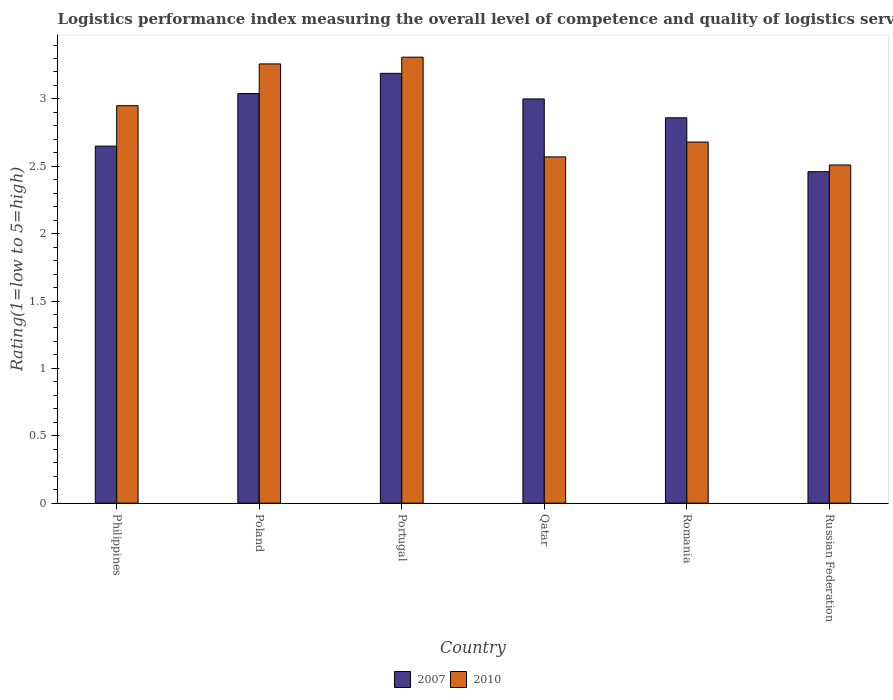How many different coloured bars are there?
Your answer should be compact. 2. How many groups of bars are there?
Your response must be concise. 6. Are the number of bars per tick equal to the number of legend labels?
Your answer should be compact. Yes. Are the number of bars on each tick of the X-axis equal?
Your answer should be very brief. Yes. How many bars are there on the 5th tick from the left?
Offer a terse response. 2. What is the label of the 6th group of bars from the left?
Give a very brief answer. Russian Federation. In how many cases, is the number of bars for a given country not equal to the number of legend labels?
Offer a very short reply. 0. What is the Logistic performance index in 2010 in Qatar?
Your answer should be very brief. 2.57. Across all countries, what is the maximum Logistic performance index in 2010?
Give a very brief answer. 3.31. Across all countries, what is the minimum Logistic performance index in 2010?
Make the answer very short. 2.51. In which country was the Logistic performance index in 2010 minimum?
Ensure brevity in your answer.  Russian Federation. What is the total Logistic performance index in 2010 in the graph?
Give a very brief answer. 17.28. What is the difference between the Logistic performance index in 2007 in Qatar and that in Russian Federation?
Offer a terse response. 0.54. What is the difference between the Logistic performance index in 2010 in Poland and the Logistic performance index in 2007 in Portugal?
Make the answer very short. 0.07. What is the average Logistic performance index in 2010 per country?
Ensure brevity in your answer.  2.88. What is the difference between the Logistic performance index of/in 2010 and Logistic performance index of/in 2007 in Philippines?
Make the answer very short. 0.3. In how many countries, is the Logistic performance index in 2007 greater than 2.3?
Keep it short and to the point. 6. What is the ratio of the Logistic performance index in 2010 in Poland to that in Romania?
Offer a very short reply. 1.22. Is the Logistic performance index in 2010 in Qatar less than that in Romania?
Your response must be concise. Yes. What is the difference between the highest and the second highest Logistic performance index in 2010?
Your answer should be compact. 0.31. What is the difference between the highest and the lowest Logistic performance index in 2007?
Your response must be concise. 0.73. In how many countries, is the Logistic performance index in 2010 greater than the average Logistic performance index in 2010 taken over all countries?
Keep it short and to the point. 3. Is the sum of the Logistic performance index in 2010 in Portugal and Qatar greater than the maximum Logistic performance index in 2007 across all countries?
Your answer should be compact. Yes. What does the 2nd bar from the left in Portugal represents?
Provide a short and direct response. 2010. What does the 1st bar from the right in Philippines represents?
Offer a very short reply. 2010. How many bars are there?
Ensure brevity in your answer.  12. How many countries are there in the graph?
Provide a short and direct response. 6. What is the difference between two consecutive major ticks on the Y-axis?
Ensure brevity in your answer.  0.5. Does the graph contain any zero values?
Offer a terse response. No. Does the graph contain grids?
Your response must be concise. No. How are the legend labels stacked?
Provide a short and direct response. Horizontal. What is the title of the graph?
Provide a short and direct response. Logistics performance index measuring the overall level of competence and quality of logistics services. What is the label or title of the Y-axis?
Your answer should be very brief. Rating(1=low to 5=high). What is the Rating(1=low to 5=high) in 2007 in Philippines?
Keep it short and to the point. 2.65. What is the Rating(1=low to 5=high) of 2010 in Philippines?
Offer a very short reply. 2.95. What is the Rating(1=low to 5=high) of 2007 in Poland?
Offer a terse response. 3.04. What is the Rating(1=low to 5=high) of 2010 in Poland?
Give a very brief answer. 3.26. What is the Rating(1=low to 5=high) of 2007 in Portugal?
Give a very brief answer. 3.19. What is the Rating(1=low to 5=high) in 2010 in Portugal?
Provide a short and direct response. 3.31. What is the Rating(1=low to 5=high) in 2010 in Qatar?
Your response must be concise. 2.57. What is the Rating(1=low to 5=high) of 2007 in Romania?
Your answer should be very brief. 2.86. What is the Rating(1=low to 5=high) in 2010 in Romania?
Your answer should be very brief. 2.68. What is the Rating(1=low to 5=high) of 2007 in Russian Federation?
Offer a very short reply. 2.46. What is the Rating(1=low to 5=high) in 2010 in Russian Federation?
Your answer should be very brief. 2.51. Across all countries, what is the maximum Rating(1=low to 5=high) in 2007?
Your answer should be compact. 3.19. Across all countries, what is the maximum Rating(1=low to 5=high) in 2010?
Provide a short and direct response. 3.31. Across all countries, what is the minimum Rating(1=low to 5=high) of 2007?
Provide a succinct answer. 2.46. Across all countries, what is the minimum Rating(1=low to 5=high) of 2010?
Provide a short and direct response. 2.51. What is the total Rating(1=low to 5=high) of 2010 in the graph?
Your response must be concise. 17.28. What is the difference between the Rating(1=low to 5=high) in 2007 in Philippines and that in Poland?
Give a very brief answer. -0.39. What is the difference between the Rating(1=low to 5=high) in 2010 in Philippines and that in Poland?
Your answer should be compact. -0.31. What is the difference between the Rating(1=low to 5=high) in 2007 in Philippines and that in Portugal?
Give a very brief answer. -0.54. What is the difference between the Rating(1=low to 5=high) of 2010 in Philippines and that in Portugal?
Ensure brevity in your answer.  -0.36. What is the difference between the Rating(1=low to 5=high) in 2007 in Philippines and that in Qatar?
Your response must be concise. -0.35. What is the difference between the Rating(1=low to 5=high) of 2010 in Philippines and that in Qatar?
Keep it short and to the point. 0.38. What is the difference between the Rating(1=low to 5=high) of 2007 in Philippines and that in Romania?
Offer a very short reply. -0.21. What is the difference between the Rating(1=low to 5=high) in 2010 in Philippines and that in Romania?
Offer a terse response. 0.27. What is the difference between the Rating(1=low to 5=high) of 2007 in Philippines and that in Russian Federation?
Make the answer very short. 0.19. What is the difference between the Rating(1=low to 5=high) of 2010 in Philippines and that in Russian Federation?
Offer a very short reply. 0.44. What is the difference between the Rating(1=low to 5=high) of 2007 in Poland and that in Portugal?
Give a very brief answer. -0.15. What is the difference between the Rating(1=low to 5=high) of 2010 in Poland and that in Portugal?
Ensure brevity in your answer.  -0.05. What is the difference between the Rating(1=low to 5=high) of 2010 in Poland and that in Qatar?
Your response must be concise. 0.69. What is the difference between the Rating(1=low to 5=high) in 2007 in Poland and that in Romania?
Your response must be concise. 0.18. What is the difference between the Rating(1=low to 5=high) in 2010 in Poland and that in Romania?
Ensure brevity in your answer.  0.58. What is the difference between the Rating(1=low to 5=high) of 2007 in Poland and that in Russian Federation?
Give a very brief answer. 0.58. What is the difference between the Rating(1=low to 5=high) of 2007 in Portugal and that in Qatar?
Offer a terse response. 0.19. What is the difference between the Rating(1=low to 5=high) in 2010 in Portugal and that in Qatar?
Your answer should be very brief. 0.74. What is the difference between the Rating(1=low to 5=high) in 2007 in Portugal and that in Romania?
Offer a terse response. 0.33. What is the difference between the Rating(1=low to 5=high) in 2010 in Portugal and that in Romania?
Your answer should be compact. 0.63. What is the difference between the Rating(1=low to 5=high) of 2007 in Portugal and that in Russian Federation?
Give a very brief answer. 0.73. What is the difference between the Rating(1=low to 5=high) in 2010 in Portugal and that in Russian Federation?
Offer a very short reply. 0.8. What is the difference between the Rating(1=low to 5=high) in 2007 in Qatar and that in Romania?
Make the answer very short. 0.14. What is the difference between the Rating(1=low to 5=high) in 2010 in Qatar and that in Romania?
Your answer should be very brief. -0.11. What is the difference between the Rating(1=low to 5=high) in 2007 in Qatar and that in Russian Federation?
Provide a succinct answer. 0.54. What is the difference between the Rating(1=low to 5=high) in 2007 in Romania and that in Russian Federation?
Your response must be concise. 0.4. What is the difference between the Rating(1=low to 5=high) in 2010 in Romania and that in Russian Federation?
Provide a succinct answer. 0.17. What is the difference between the Rating(1=low to 5=high) in 2007 in Philippines and the Rating(1=low to 5=high) in 2010 in Poland?
Offer a terse response. -0.61. What is the difference between the Rating(1=low to 5=high) in 2007 in Philippines and the Rating(1=low to 5=high) in 2010 in Portugal?
Make the answer very short. -0.66. What is the difference between the Rating(1=low to 5=high) in 2007 in Philippines and the Rating(1=low to 5=high) in 2010 in Qatar?
Provide a short and direct response. 0.08. What is the difference between the Rating(1=low to 5=high) of 2007 in Philippines and the Rating(1=low to 5=high) of 2010 in Romania?
Offer a very short reply. -0.03. What is the difference between the Rating(1=low to 5=high) of 2007 in Philippines and the Rating(1=low to 5=high) of 2010 in Russian Federation?
Give a very brief answer. 0.14. What is the difference between the Rating(1=low to 5=high) of 2007 in Poland and the Rating(1=low to 5=high) of 2010 in Portugal?
Your answer should be very brief. -0.27. What is the difference between the Rating(1=low to 5=high) in 2007 in Poland and the Rating(1=low to 5=high) in 2010 in Qatar?
Offer a terse response. 0.47. What is the difference between the Rating(1=low to 5=high) in 2007 in Poland and the Rating(1=low to 5=high) in 2010 in Romania?
Your response must be concise. 0.36. What is the difference between the Rating(1=low to 5=high) in 2007 in Poland and the Rating(1=low to 5=high) in 2010 in Russian Federation?
Your answer should be very brief. 0.53. What is the difference between the Rating(1=low to 5=high) of 2007 in Portugal and the Rating(1=low to 5=high) of 2010 in Qatar?
Provide a short and direct response. 0.62. What is the difference between the Rating(1=low to 5=high) in 2007 in Portugal and the Rating(1=low to 5=high) in 2010 in Romania?
Ensure brevity in your answer.  0.51. What is the difference between the Rating(1=low to 5=high) in 2007 in Portugal and the Rating(1=low to 5=high) in 2010 in Russian Federation?
Provide a short and direct response. 0.68. What is the difference between the Rating(1=low to 5=high) in 2007 in Qatar and the Rating(1=low to 5=high) in 2010 in Romania?
Give a very brief answer. 0.32. What is the difference between the Rating(1=low to 5=high) in 2007 in Qatar and the Rating(1=low to 5=high) in 2010 in Russian Federation?
Your answer should be compact. 0.49. What is the difference between the Rating(1=low to 5=high) in 2007 in Romania and the Rating(1=low to 5=high) in 2010 in Russian Federation?
Keep it short and to the point. 0.35. What is the average Rating(1=low to 5=high) in 2007 per country?
Your answer should be compact. 2.87. What is the average Rating(1=low to 5=high) in 2010 per country?
Keep it short and to the point. 2.88. What is the difference between the Rating(1=low to 5=high) of 2007 and Rating(1=low to 5=high) of 2010 in Philippines?
Make the answer very short. -0.3. What is the difference between the Rating(1=low to 5=high) of 2007 and Rating(1=low to 5=high) of 2010 in Poland?
Offer a terse response. -0.22. What is the difference between the Rating(1=low to 5=high) of 2007 and Rating(1=low to 5=high) of 2010 in Portugal?
Provide a succinct answer. -0.12. What is the difference between the Rating(1=low to 5=high) of 2007 and Rating(1=low to 5=high) of 2010 in Qatar?
Provide a succinct answer. 0.43. What is the difference between the Rating(1=low to 5=high) in 2007 and Rating(1=low to 5=high) in 2010 in Romania?
Offer a very short reply. 0.18. What is the ratio of the Rating(1=low to 5=high) of 2007 in Philippines to that in Poland?
Offer a terse response. 0.87. What is the ratio of the Rating(1=low to 5=high) in 2010 in Philippines to that in Poland?
Your answer should be very brief. 0.9. What is the ratio of the Rating(1=low to 5=high) of 2007 in Philippines to that in Portugal?
Provide a succinct answer. 0.83. What is the ratio of the Rating(1=low to 5=high) in 2010 in Philippines to that in Portugal?
Keep it short and to the point. 0.89. What is the ratio of the Rating(1=low to 5=high) of 2007 in Philippines to that in Qatar?
Ensure brevity in your answer.  0.88. What is the ratio of the Rating(1=low to 5=high) of 2010 in Philippines to that in Qatar?
Your answer should be compact. 1.15. What is the ratio of the Rating(1=low to 5=high) in 2007 in Philippines to that in Romania?
Make the answer very short. 0.93. What is the ratio of the Rating(1=low to 5=high) in 2010 in Philippines to that in Romania?
Provide a succinct answer. 1.1. What is the ratio of the Rating(1=low to 5=high) of 2007 in Philippines to that in Russian Federation?
Your answer should be compact. 1.08. What is the ratio of the Rating(1=low to 5=high) in 2010 in Philippines to that in Russian Federation?
Offer a very short reply. 1.18. What is the ratio of the Rating(1=low to 5=high) in 2007 in Poland to that in Portugal?
Your answer should be very brief. 0.95. What is the ratio of the Rating(1=low to 5=high) in 2010 in Poland to that in Portugal?
Make the answer very short. 0.98. What is the ratio of the Rating(1=low to 5=high) of 2007 in Poland to that in Qatar?
Your response must be concise. 1.01. What is the ratio of the Rating(1=low to 5=high) of 2010 in Poland to that in Qatar?
Offer a terse response. 1.27. What is the ratio of the Rating(1=low to 5=high) in 2007 in Poland to that in Romania?
Provide a short and direct response. 1.06. What is the ratio of the Rating(1=low to 5=high) in 2010 in Poland to that in Romania?
Offer a very short reply. 1.22. What is the ratio of the Rating(1=low to 5=high) of 2007 in Poland to that in Russian Federation?
Make the answer very short. 1.24. What is the ratio of the Rating(1=low to 5=high) in 2010 in Poland to that in Russian Federation?
Keep it short and to the point. 1.3. What is the ratio of the Rating(1=low to 5=high) of 2007 in Portugal to that in Qatar?
Your response must be concise. 1.06. What is the ratio of the Rating(1=low to 5=high) in 2010 in Portugal to that in Qatar?
Provide a succinct answer. 1.29. What is the ratio of the Rating(1=low to 5=high) of 2007 in Portugal to that in Romania?
Give a very brief answer. 1.12. What is the ratio of the Rating(1=low to 5=high) in 2010 in Portugal to that in Romania?
Provide a succinct answer. 1.24. What is the ratio of the Rating(1=low to 5=high) of 2007 in Portugal to that in Russian Federation?
Keep it short and to the point. 1.3. What is the ratio of the Rating(1=low to 5=high) of 2010 in Portugal to that in Russian Federation?
Keep it short and to the point. 1.32. What is the ratio of the Rating(1=low to 5=high) of 2007 in Qatar to that in Romania?
Give a very brief answer. 1.05. What is the ratio of the Rating(1=low to 5=high) of 2007 in Qatar to that in Russian Federation?
Offer a very short reply. 1.22. What is the ratio of the Rating(1=low to 5=high) of 2010 in Qatar to that in Russian Federation?
Make the answer very short. 1.02. What is the ratio of the Rating(1=low to 5=high) in 2007 in Romania to that in Russian Federation?
Offer a terse response. 1.16. What is the ratio of the Rating(1=low to 5=high) in 2010 in Romania to that in Russian Federation?
Your response must be concise. 1.07. What is the difference between the highest and the second highest Rating(1=low to 5=high) in 2007?
Offer a very short reply. 0.15. What is the difference between the highest and the second highest Rating(1=low to 5=high) of 2010?
Offer a terse response. 0.05. What is the difference between the highest and the lowest Rating(1=low to 5=high) in 2007?
Give a very brief answer. 0.73. What is the difference between the highest and the lowest Rating(1=low to 5=high) in 2010?
Ensure brevity in your answer.  0.8. 